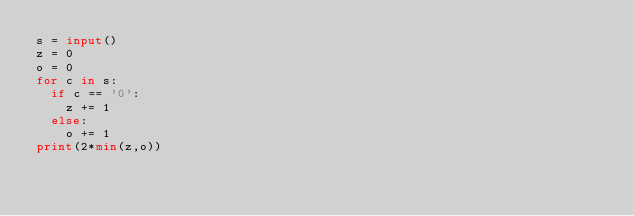Convert code to text. <code><loc_0><loc_0><loc_500><loc_500><_Python_>s = input()
z = 0
o = 0
for c in s:
  if c == '0':
    z += 1
  else:
    o += 1
print(2*min(z,o))</code> 